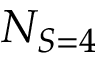<formula> <loc_0><loc_0><loc_500><loc_500>N _ { S = 4 }</formula> 